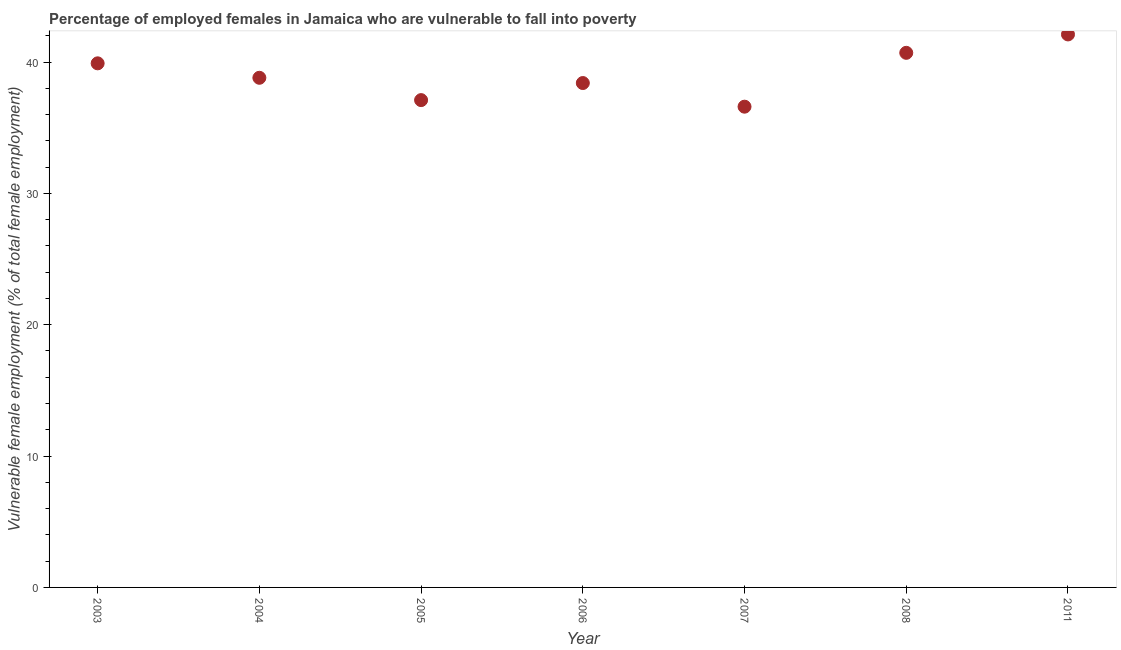What is the percentage of employed females who are vulnerable to fall into poverty in 2004?
Your answer should be compact. 38.8. Across all years, what is the maximum percentage of employed females who are vulnerable to fall into poverty?
Ensure brevity in your answer.  42.1. Across all years, what is the minimum percentage of employed females who are vulnerable to fall into poverty?
Provide a short and direct response. 36.6. What is the sum of the percentage of employed females who are vulnerable to fall into poverty?
Your answer should be very brief. 273.6. What is the difference between the percentage of employed females who are vulnerable to fall into poverty in 2004 and 2007?
Offer a terse response. 2.2. What is the average percentage of employed females who are vulnerable to fall into poverty per year?
Provide a succinct answer. 39.09. What is the median percentage of employed females who are vulnerable to fall into poverty?
Make the answer very short. 38.8. In how many years, is the percentage of employed females who are vulnerable to fall into poverty greater than 36 %?
Ensure brevity in your answer.  7. What is the ratio of the percentage of employed females who are vulnerable to fall into poverty in 2003 to that in 2008?
Your answer should be compact. 0.98. What is the difference between the highest and the second highest percentage of employed females who are vulnerable to fall into poverty?
Make the answer very short. 1.4. What is the difference between the highest and the lowest percentage of employed females who are vulnerable to fall into poverty?
Your response must be concise. 5.5. In how many years, is the percentage of employed females who are vulnerable to fall into poverty greater than the average percentage of employed females who are vulnerable to fall into poverty taken over all years?
Your answer should be compact. 3. Does the percentage of employed females who are vulnerable to fall into poverty monotonically increase over the years?
Offer a terse response. No. How many dotlines are there?
Offer a terse response. 1. Does the graph contain grids?
Provide a succinct answer. No. What is the title of the graph?
Your response must be concise. Percentage of employed females in Jamaica who are vulnerable to fall into poverty. What is the label or title of the Y-axis?
Ensure brevity in your answer.  Vulnerable female employment (% of total female employment). What is the Vulnerable female employment (% of total female employment) in 2003?
Make the answer very short. 39.9. What is the Vulnerable female employment (% of total female employment) in 2004?
Provide a short and direct response. 38.8. What is the Vulnerable female employment (% of total female employment) in 2005?
Provide a succinct answer. 37.1. What is the Vulnerable female employment (% of total female employment) in 2006?
Give a very brief answer. 38.4. What is the Vulnerable female employment (% of total female employment) in 2007?
Your response must be concise. 36.6. What is the Vulnerable female employment (% of total female employment) in 2008?
Give a very brief answer. 40.7. What is the Vulnerable female employment (% of total female employment) in 2011?
Offer a terse response. 42.1. What is the difference between the Vulnerable female employment (% of total female employment) in 2003 and 2007?
Keep it short and to the point. 3.3. What is the difference between the Vulnerable female employment (% of total female employment) in 2003 and 2008?
Make the answer very short. -0.8. What is the difference between the Vulnerable female employment (% of total female employment) in 2003 and 2011?
Your response must be concise. -2.2. What is the difference between the Vulnerable female employment (% of total female employment) in 2004 and 2005?
Make the answer very short. 1.7. What is the difference between the Vulnerable female employment (% of total female employment) in 2004 and 2008?
Provide a succinct answer. -1.9. What is the difference between the Vulnerable female employment (% of total female employment) in 2004 and 2011?
Your answer should be very brief. -3.3. What is the difference between the Vulnerable female employment (% of total female employment) in 2005 and 2006?
Offer a very short reply. -1.3. What is the difference between the Vulnerable female employment (% of total female employment) in 2005 and 2007?
Offer a terse response. 0.5. What is the difference between the Vulnerable female employment (% of total female employment) in 2005 and 2008?
Offer a very short reply. -3.6. What is the difference between the Vulnerable female employment (% of total female employment) in 2005 and 2011?
Your answer should be very brief. -5. What is the difference between the Vulnerable female employment (% of total female employment) in 2006 and 2008?
Offer a terse response. -2.3. What is the difference between the Vulnerable female employment (% of total female employment) in 2007 and 2008?
Provide a short and direct response. -4.1. What is the difference between the Vulnerable female employment (% of total female employment) in 2007 and 2011?
Your response must be concise. -5.5. What is the difference between the Vulnerable female employment (% of total female employment) in 2008 and 2011?
Make the answer very short. -1.4. What is the ratio of the Vulnerable female employment (% of total female employment) in 2003 to that in 2004?
Provide a short and direct response. 1.03. What is the ratio of the Vulnerable female employment (% of total female employment) in 2003 to that in 2005?
Give a very brief answer. 1.07. What is the ratio of the Vulnerable female employment (% of total female employment) in 2003 to that in 2006?
Ensure brevity in your answer.  1.04. What is the ratio of the Vulnerable female employment (% of total female employment) in 2003 to that in 2007?
Provide a short and direct response. 1.09. What is the ratio of the Vulnerable female employment (% of total female employment) in 2003 to that in 2008?
Your answer should be compact. 0.98. What is the ratio of the Vulnerable female employment (% of total female employment) in 2003 to that in 2011?
Your answer should be compact. 0.95. What is the ratio of the Vulnerable female employment (% of total female employment) in 2004 to that in 2005?
Offer a terse response. 1.05. What is the ratio of the Vulnerable female employment (% of total female employment) in 2004 to that in 2006?
Give a very brief answer. 1.01. What is the ratio of the Vulnerable female employment (% of total female employment) in 2004 to that in 2007?
Make the answer very short. 1.06. What is the ratio of the Vulnerable female employment (% of total female employment) in 2004 to that in 2008?
Your response must be concise. 0.95. What is the ratio of the Vulnerable female employment (% of total female employment) in 2004 to that in 2011?
Offer a terse response. 0.92. What is the ratio of the Vulnerable female employment (% of total female employment) in 2005 to that in 2006?
Ensure brevity in your answer.  0.97. What is the ratio of the Vulnerable female employment (% of total female employment) in 2005 to that in 2008?
Ensure brevity in your answer.  0.91. What is the ratio of the Vulnerable female employment (% of total female employment) in 2005 to that in 2011?
Give a very brief answer. 0.88. What is the ratio of the Vulnerable female employment (% of total female employment) in 2006 to that in 2007?
Offer a very short reply. 1.05. What is the ratio of the Vulnerable female employment (% of total female employment) in 2006 to that in 2008?
Ensure brevity in your answer.  0.94. What is the ratio of the Vulnerable female employment (% of total female employment) in 2006 to that in 2011?
Give a very brief answer. 0.91. What is the ratio of the Vulnerable female employment (% of total female employment) in 2007 to that in 2008?
Offer a terse response. 0.9. What is the ratio of the Vulnerable female employment (% of total female employment) in 2007 to that in 2011?
Ensure brevity in your answer.  0.87. What is the ratio of the Vulnerable female employment (% of total female employment) in 2008 to that in 2011?
Make the answer very short. 0.97. 